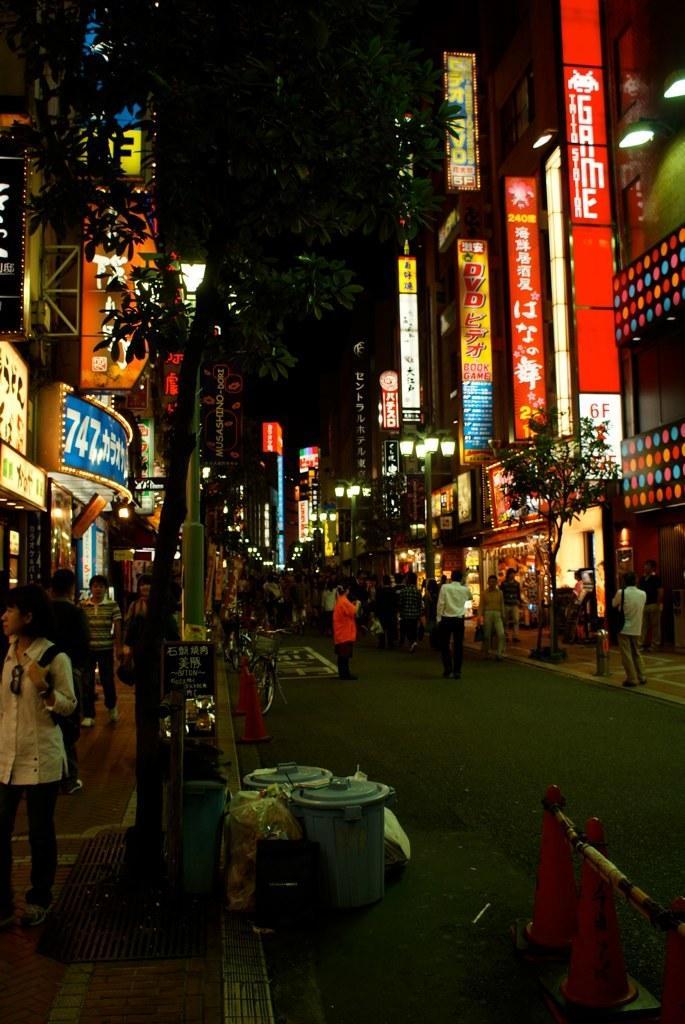Can you describe this image briefly? In this image there is a road in the bottom of this image. There are some persons standing on the road and on the left side of this image. There are some trees on the left side of this image and right side of this image as well. There are some buildings in the background. There are some objects kept on to this road, and there are two bicycles as we can see in the middle of this image. 